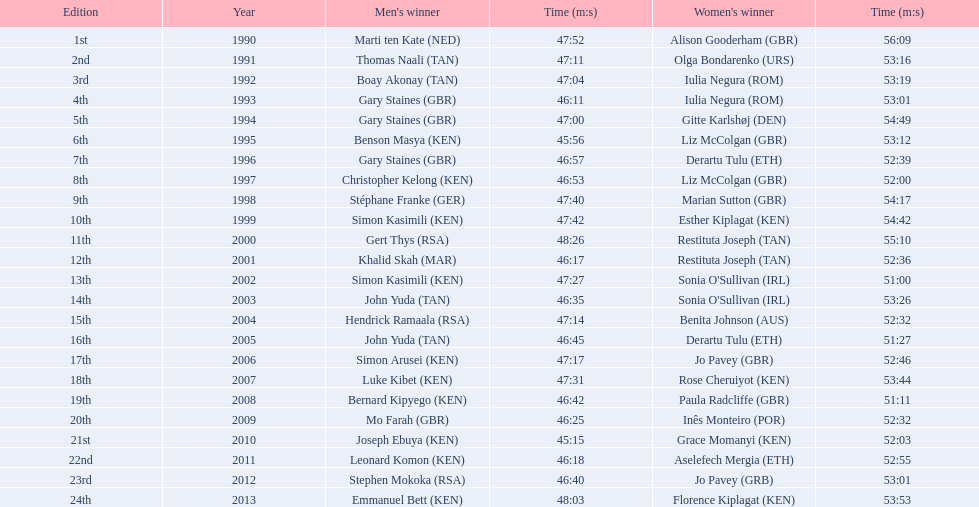Which athletes hail from kenya? Benson Masya (KEN), Christopher Kelong (KEN), Simon Kasimili (KEN), Simon Kasimili (KEN), Simon Arusei (KEN), Luke Kibet (KEN), Bernard Kipyego (KEN), Joseph Ebuya (KEN), Leonard Komon (KEN), Emmanuel Bett (KEN). Among them, who has a time below 46 minutes? Benson Masya (KEN), Joseph Ebuya (KEN). Who among these runners has the quickest time? Joseph Ebuya (KEN). 